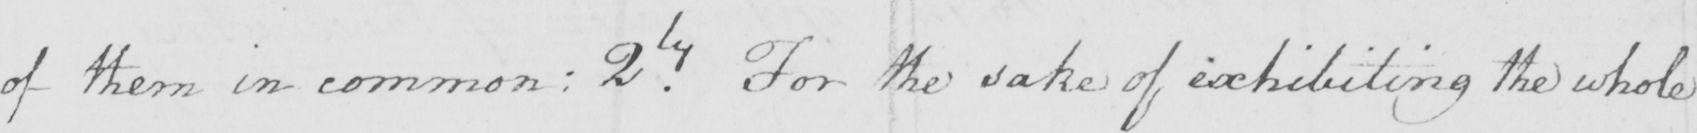What does this handwritten line say? of them in common :  2ly For the sake of exhibiting the whole 